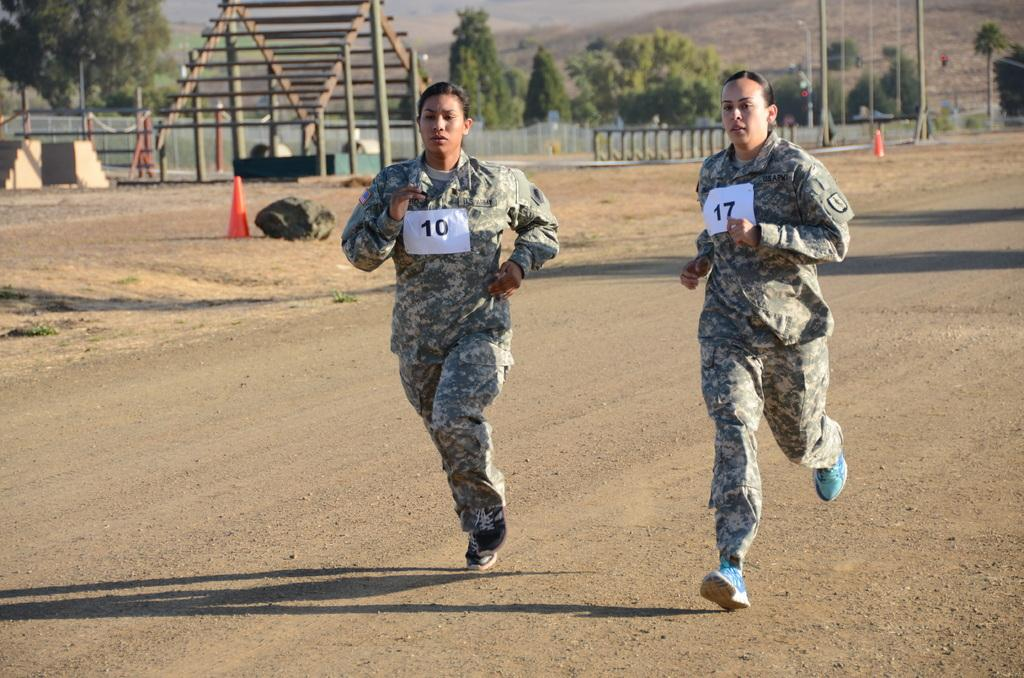What are the two women in the image doing? The two women in the image are running on the road. What can be seen at the top of the image? Boards, a fence, trees, divider blocks, and a tent house are visible at the top of the image. What month is it in the image? The month cannot be determined from the image, as there is no information about the time of year or any seasonal indicators present. What fact can be learned about the fork in the image? There is no fork present in the image, so no fact about a fork can be learned. 